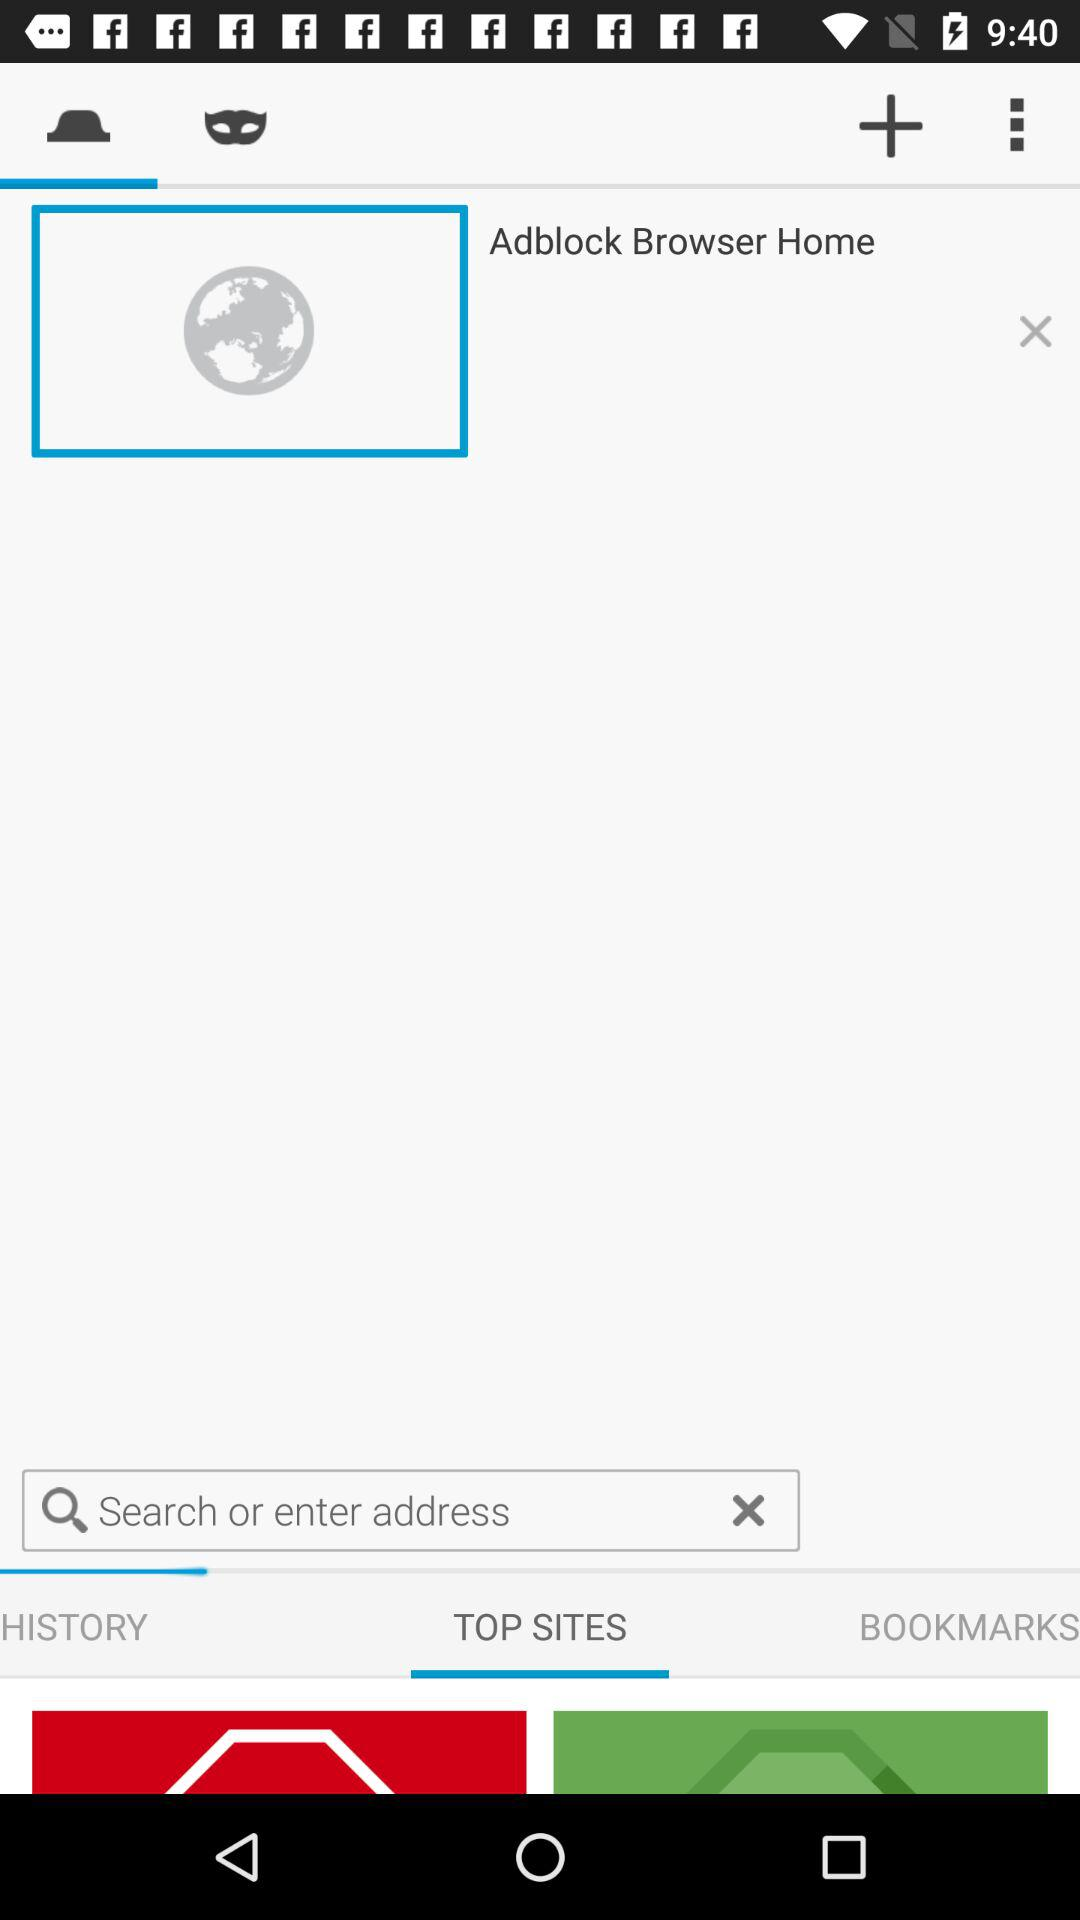What is the name of the given browser? The name of the browser is "Adblock". 